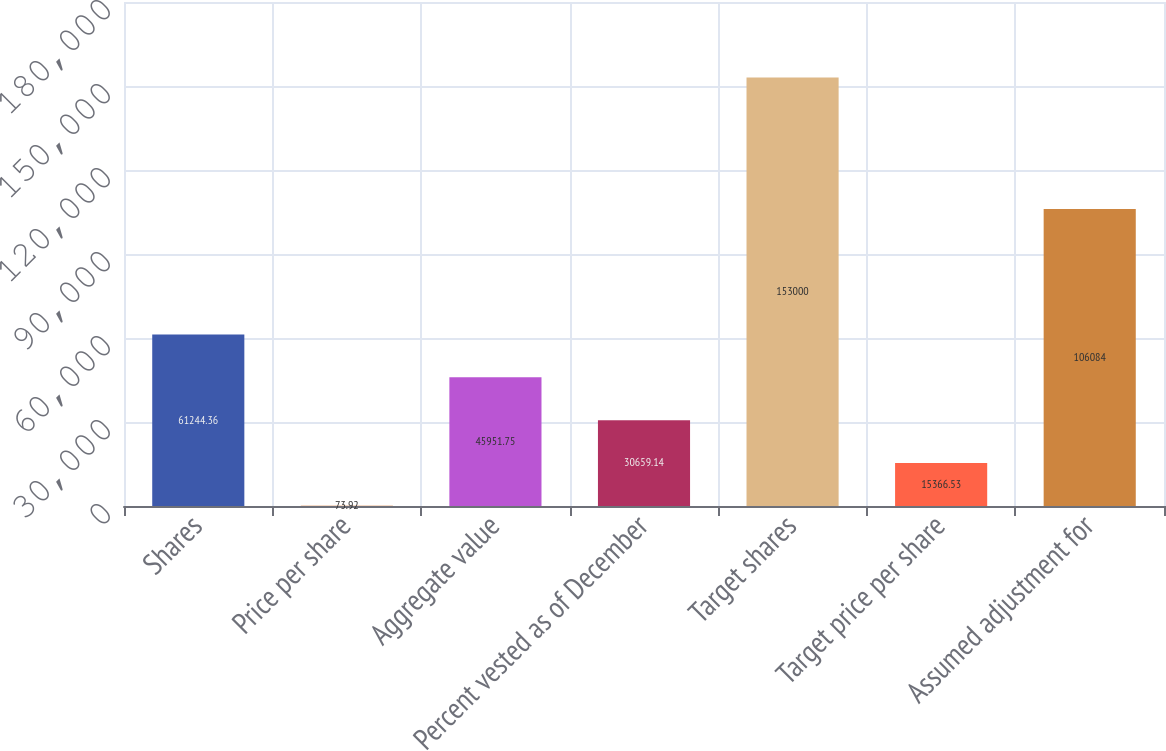Convert chart to OTSL. <chart><loc_0><loc_0><loc_500><loc_500><bar_chart><fcel>Shares<fcel>Price per share<fcel>Aggregate value<fcel>Percent vested as of December<fcel>Target shares<fcel>Target price per share<fcel>Assumed adjustment for<nl><fcel>61244.4<fcel>73.92<fcel>45951.8<fcel>30659.1<fcel>153000<fcel>15366.5<fcel>106084<nl></chart> 